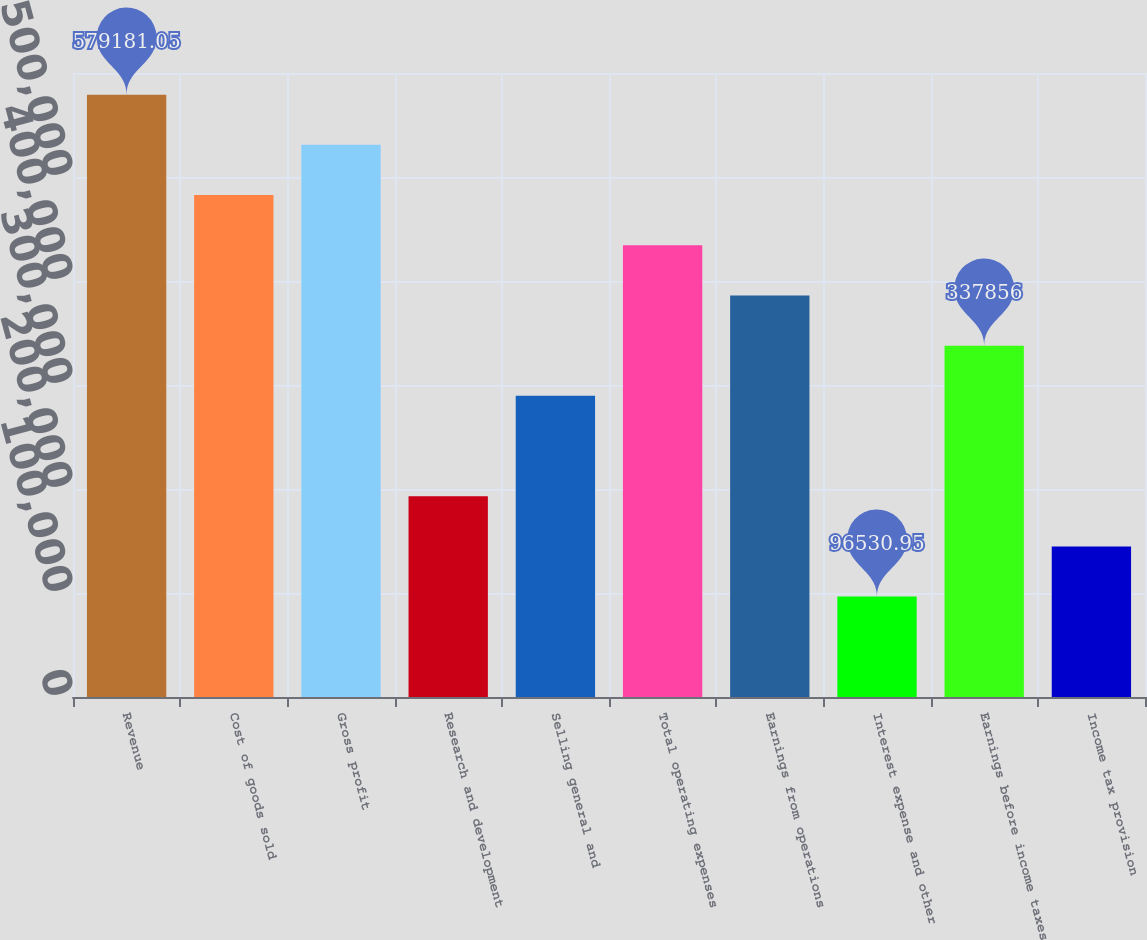Convert chart to OTSL. <chart><loc_0><loc_0><loc_500><loc_500><bar_chart><fcel>Revenue<fcel>Cost of goods sold<fcel>Gross profit<fcel>Research and development<fcel>Selling general and<fcel>Total operating expenses<fcel>Earnings from operations<fcel>Interest expense and other<fcel>Earnings before income taxes<fcel>Income tax provision<nl><fcel>579181<fcel>482651<fcel>530916<fcel>193061<fcel>289591<fcel>434386<fcel>386121<fcel>96530.9<fcel>337856<fcel>144796<nl></chart> 